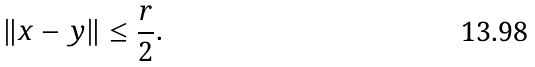<formula> <loc_0><loc_0><loc_500><loc_500>\left \| x - y \right \| \leq \frac { r } { 2 } .</formula> 